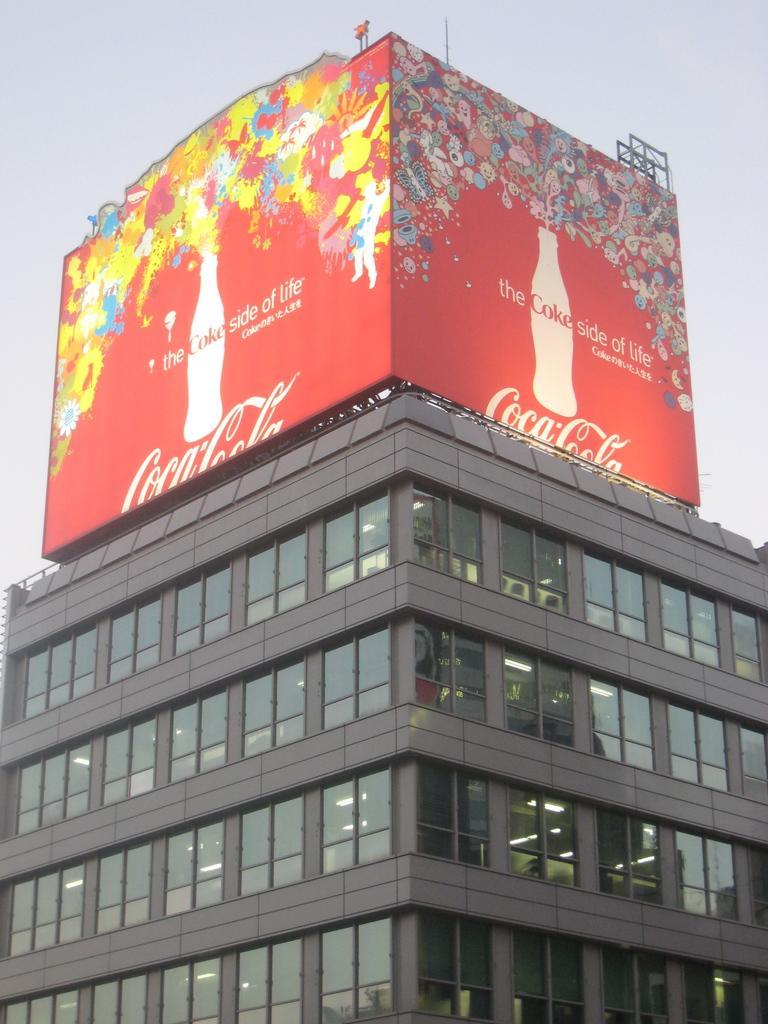Could you give a brief overview of what you see in this image? In this image, on the foreground there is a building and above this building there is a coca cola poster. 